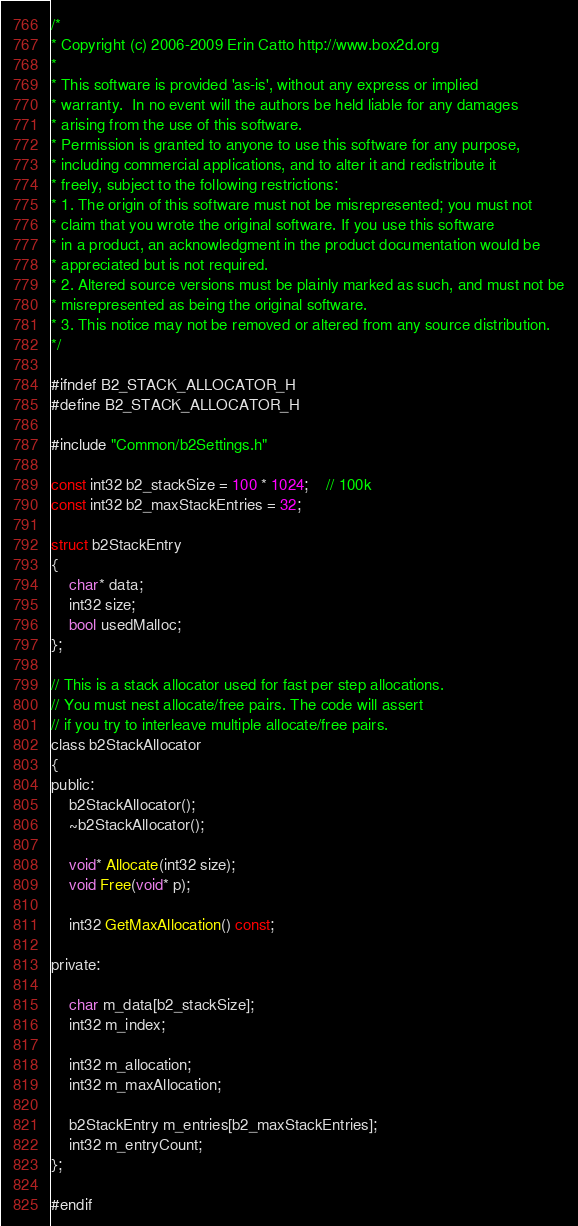Convert code to text. <code><loc_0><loc_0><loc_500><loc_500><_C_>/*
* Copyright (c) 2006-2009 Erin Catto http://www.box2d.org
*
* This software is provided 'as-is', without any express or implied
* warranty.  In no event will the authors be held liable for any damages
* arising from the use of this software.
* Permission is granted to anyone to use this software for any purpose,
* including commercial applications, and to alter it and redistribute it
* freely, subject to the following restrictions:
* 1. The origin of this software must not be misrepresented; you must not
* claim that you wrote the original software. If you use this software
* in a product, an acknowledgment in the product documentation would be
* appreciated but is not required.
* 2. Altered source versions must be plainly marked as such, and must not be
* misrepresented as being the original software.
* 3. This notice may not be removed or altered from any source distribution.
*/

#ifndef B2_STACK_ALLOCATOR_H
#define B2_STACK_ALLOCATOR_H

#include "Common/b2Settings.h"

const int32 b2_stackSize = 100 * 1024;	// 100k
const int32 b2_maxStackEntries = 32;

struct b2StackEntry
{
	char* data;
	int32 size;
	bool usedMalloc;
};

// This is a stack allocator used for fast per step allocations.
// You must nest allocate/free pairs. The code will assert
// if you try to interleave multiple allocate/free pairs.
class b2StackAllocator
{
public:
	b2StackAllocator();
	~b2StackAllocator();

	void* Allocate(int32 size);
	void Free(void* p);

	int32 GetMaxAllocation() const;

private:

	char m_data[b2_stackSize];
	int32 m_index;

	int32 m_allocation;
	int32 m_maxAllocation;

	b2StackEntry m_entries[b2_maxStackEntries];
	int32 m_entryCount;
};

#endif
</code> 